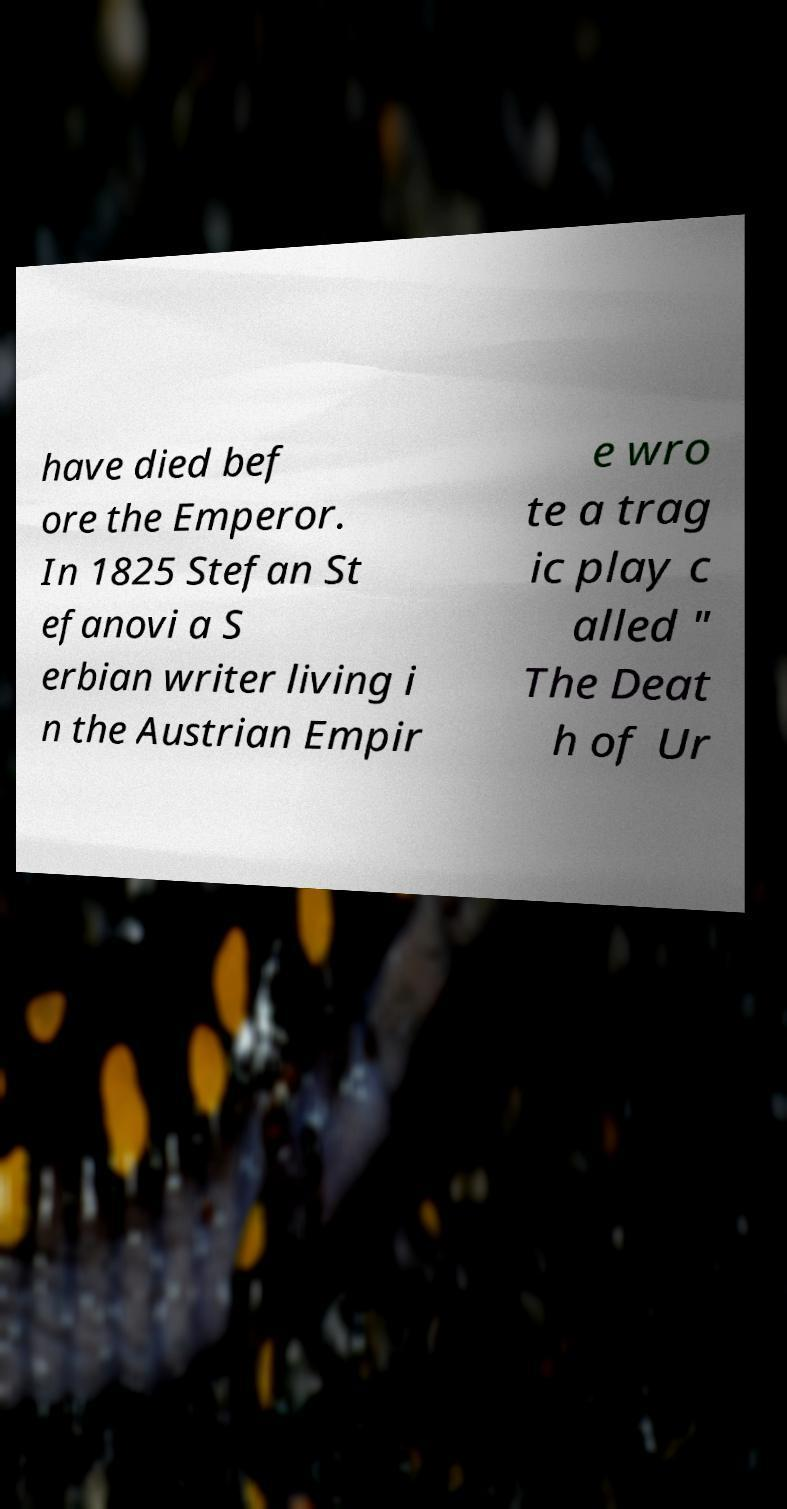Could you extract and type out the text from this image? have died bef ore the Emperor. In 1825 Stefan St efanovi a S erbian writer living i n the Austrian Empir e wro te a trag ic play c alled " The Deat h of Ur 